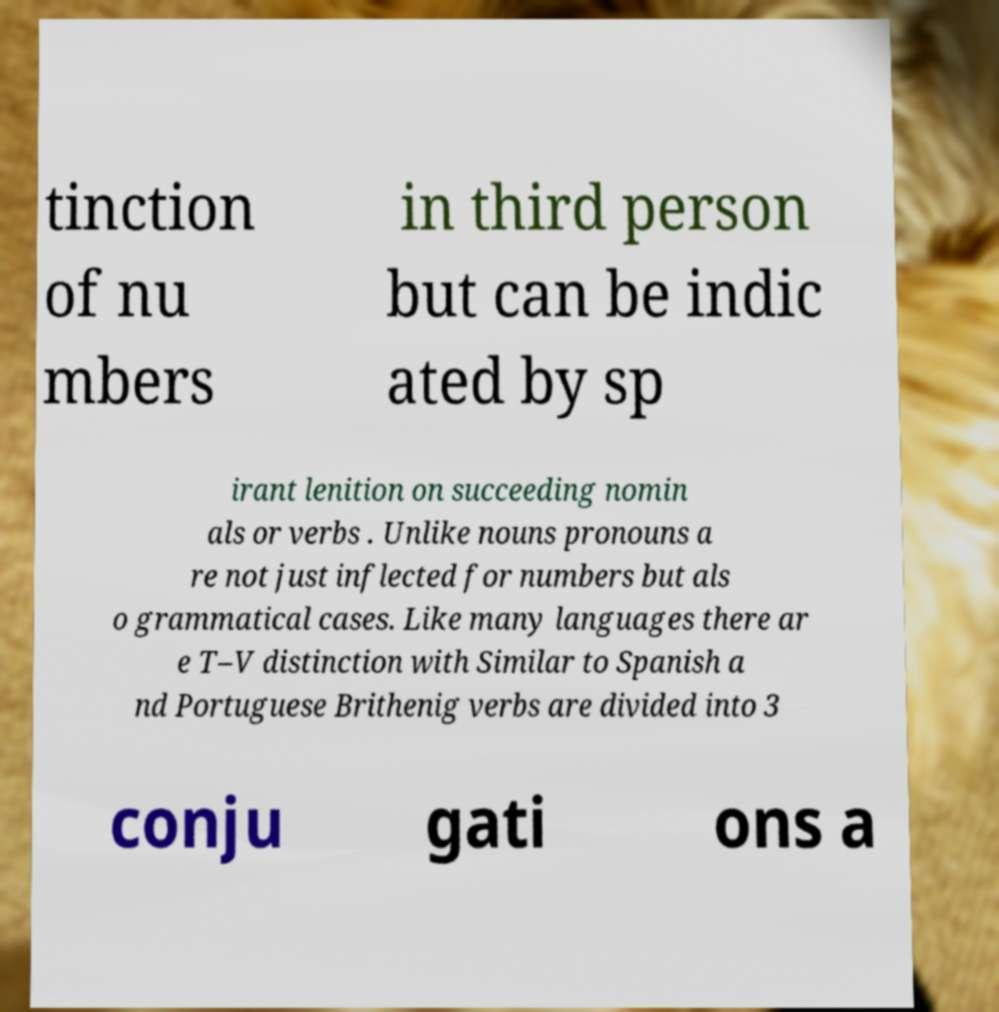What messages or text are displayed in this image? I need them in a readable, typed format. tinction of nu mbers in third person but can be indic ated by sp irant lenition on succeeding nomin als or verbs . Unlike nouns pronouns a re not just inflected for numbers but als o grammatical cases. Like many languages there ar e T–V distinction with Similar to Spanish a nd Portuguese Brithenig verbs are divided into 3 conju gati ons a 